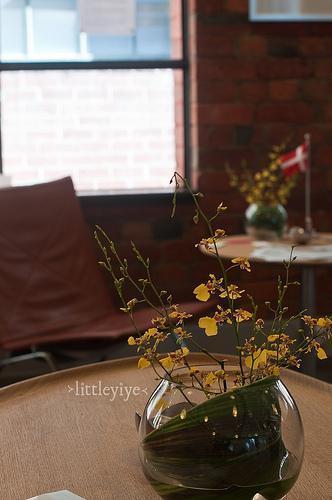How many potted plants are visible?
Give a very brief answer. 2. How many flags are visible in this photo?
Give a very brief answer. 1. 